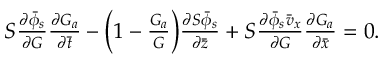<formula> <loc_0><loc_0><loc_500><loc_500>\begin{array} { r } { S \frac { \partial \bar { \phi } _ { s } } { \partial G } \frac { \partial G _ { a } } { \partial \bar { t } } - \left ( 1 - \frac { G _ { a } } { G } \right ) \frac { \partial S \bar { \phi } _ { s } } { \partial \bar { z } } + S \frac { \partial \bar { \phi } _ { s } \bar { v } _ { x } } { \partial G } \frac { \partial G _ { a } } { \partial \bar { x } } = 0 . } \end{array}</formula> 